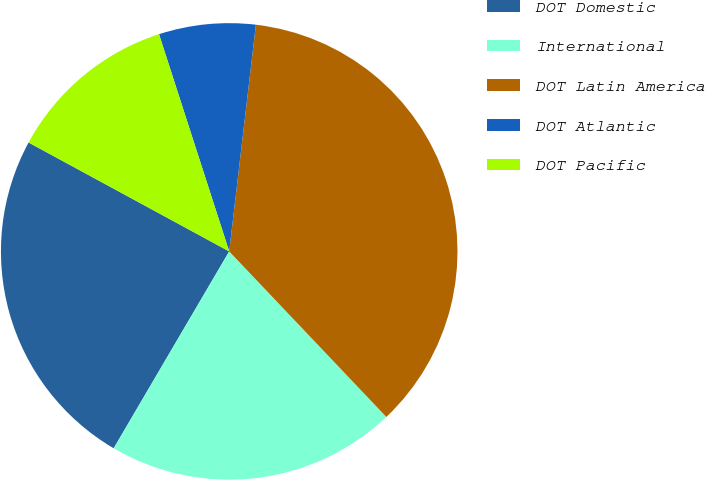Convert chart to OTSL. <chart><loc_0><loc_0><loc_500><loc_500><pie_chart><fcel>DOT Domestic<fcel>International<fcel>DOT Latin America<fcel>DOT Atlantic<fcel>DOT Pacific<nl><fcel>24.47%<fcel>20.53%<fcel>36.05%<fcel>6.84%<fcel>12.11%<nl></chart> 